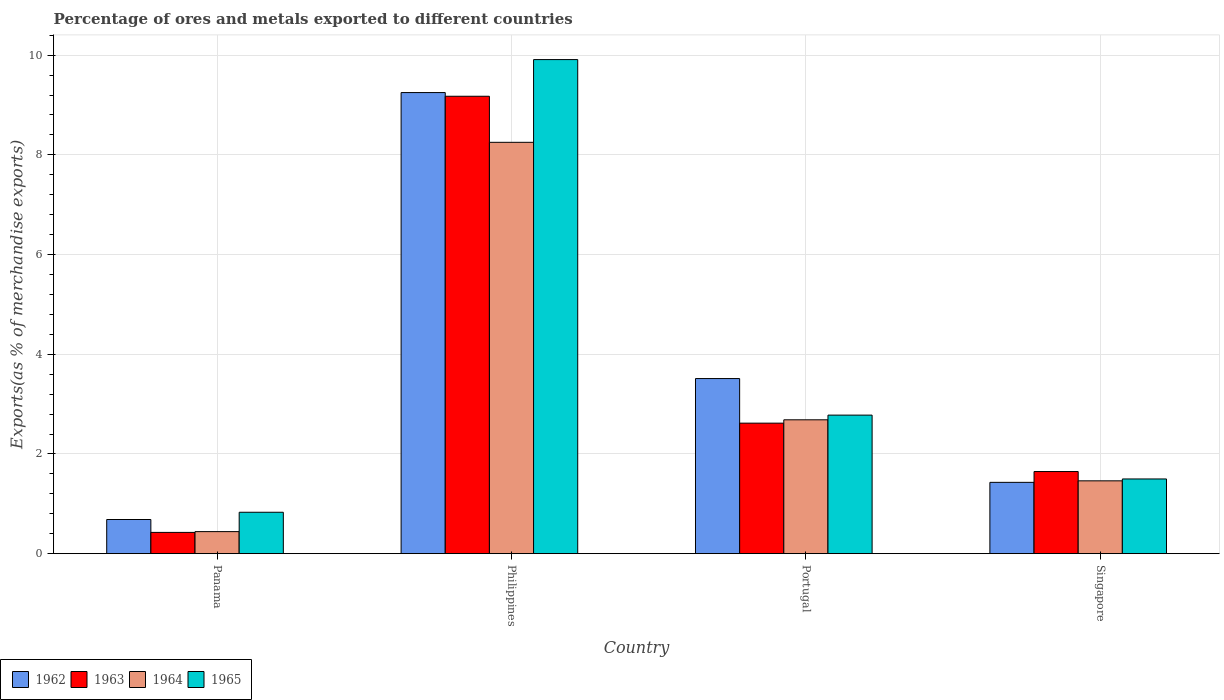How many different coloured bars are there?
Provide a succinct answer. 4. Are the number of bars per tick equal to the number of legend labels?
Give a very brief answer. Yes. Are the number of bars on each tick of the X-axis equal?
Make the answer very short. Yes. How many bars are there on the 3rd tick from the right?
Offer a terse response. 4. What is the label of the 1st group of bars from the left?
Offer a terse response. Panama. In how many cases, is the number of bars for a given country not equal to the number of legend labels?
Your answer should be very brief. 0. What is the percentage of exports to different countries in 1965 in Panama?
Offer a very short reply. 0.83. Across all countries, what is the maximum percentage of exports to different countries in 1963?
Your answer should be compact. 9.18. Across all countries, what is the minimum percentage of exports to different countries in 1964?
Provide a succinct answer. 0.44. In which country was the percentage of exports to different countries in 1963 minimum?
Ensure brevity in your answer.  Panama. What is the total percentage of exports to different countries in 1965 in the graph?
Your answer should be very brief. 15.02. What is the difference between the percentage of exports to different countries in 1963 in Portugal and that in Singapore?
Your response must be concise. 0.97. What is the difference between the percentage of exports to different countries in 1964 in Singapore and the percentage of exports to different countries in 1965 in Portugal?
Ensure brevity in your answer.  -1.32. What is the average percentage of exports to different countries in 1963 per country?
Offer a terse response. 3.47. What is the difference between the percentage of exports to different countries of/in 1963 and percentage of exports to different countries of/in 1962 in Portugal?
Ensure brevity in your answer.  -0.89. What is the ratio of the percentage of exports to different countries in 1962 in Panama to that in Singapore?
Make the answer very short. 0.48. Is the percentage of exports to different countries in 1962 in Panama less than that in Philippines?
Provide a succinct answer. Yes. What is the difference between the highest and the second highest percentage of exports to different countries in 1964?
Keep it short and to the point. 6.79. What is the difference between the highest and the lowest percentage of exports to different countries in 1963?
Offer a very short reply. 8.75. In how many countries, is the percentage of exports to different countries in 1964 greater than the average percentage of exports to different countries in 1964 taken over all countries?
Provide a short and direct response. 1. Is the sum of the percentage of exports to different countries in 1963 in Philippines and Singapore greater than the maximum percentage of exports to different countries in 1962 across all countries?
Ensure brevity in your answer.  Yes. What does the 1st bar from the right in Panama represents?
Your response must be concise. 1965. What is the difference between two consecutive major ticks on the Y-axis?
Make the answer very short. 2. Does the graph contain any zero values?
Provide a succinct answer. No. How are the legend labels stacked?
Keep it short and to the point. Horizontal. What is the title of the graph?
Your response must be concise. Percentage of ores and metals exported to different countries. What is the label or title of the X-axis?
Your answer should be very brief. Country. What is the label or title of the Y-axis?
Keep it short and to the point. Exports(as % of merchandise exports). What is the Exports(as % of merchandise exports) in 1962 in Panama?
Provide a short and direct response. 0.69. What is the Exports(as % of merchandise exports) of 1963 in Panama?
Provide a short and direct response. 0.43. What is the Exports(as % of merchandise exports) in 1964 in Panama?
Your response must be concise. 0.44. What is the Exports(as % of merchandise exports) of 1965 in Panama?
Ensure brevity in your answer.  0.83. What is the Exports(as % of merchandise exports) in 1962 in Philippines?
Provide a short and direct response. 9.25. What is the Exports(as % of merchandise exports) of 1963 in Philippines?
Your answer should be very brief. 9.18. What is the Exports(as % of merchandise exports) in 1964 in Philippines?
Your answer should be very brief. 8.25. What is the Exports(as % of merchandise exports) of 1965 in Philippines?
Offer a very short reply. 9.91. What is the Exports(as % of merchandise exports) in 1962 in Portugal?
Make the answer very short. 3.51. What is the Exports(as % of merchandise exports) in 1963 in Portugal?
Make the answer very short. 2.62. What is the Exports(as % of merchandise exports) in 1964 in Portugal?
Offer a terse response. 2.69. What is the Exports(as % of merchandise exports) of 1965 in Portugal?
Your answer should be compact. 2.78. What is the Exports(as % of merchandise exports) of 1962 in Singapore?
Provide a short and direct response. 1.43. What is the Exports(as % of merchandise exports) of 1963 in Singapore?
Provide a short and direct response. 1.65. What is the Exports(as % of merchandise exports) of 1964 in Singapore?
Provide a short and direct response. 1.46. What is the Exports(as % of merchandise exports) of 1965 in Singapore?
Your response must be concise. 1.5. Across all countries, what is the maximum Exports(as % of merchandise exports) in 1962?
Your answer should be compact. 9.25. Across all countries, what is the maximum Exports(as % of merchandise exports) of 1963?
Your response must be concise. 9.18. Across all countries, what is the maximum Exports(as % of merchandise exports) of 1964?
Give a very brief answer. 8.25. Across all countries, what is the maximum Exports(as % of merchandise exports) in 1965?
Make the answer very short. 9.91. Across all countries, what is the minimum Exports(as % of merchandise exports) of 1962?
Keep it short and to the point. 0.69. Across all countries, what is the minimum Exports(as % of merchandise exports) in 1963?
Give a very brief answer. 0.43. Across all countries, what is the minimum Exports(as % of merchandise exports) of 1964?
Your answer should be compact. 0.44. Across all countries, what is the minimum Exports(as % of merchandise exports) in 1965?
Provide a short and direct response. 0.83. What is the total Exports(as % of merchandise exports) of 1962 in the graph?
Offer a very short reply. 14.88. What is the total Exports(as % of merchandise exports) in 1963 in the graph?
Your answer should be compact. 13.87. What is the total Exports(as % of merchandise exports) in 1964 in the graph?
Your answer should be very brief. 12.84. What is the total Exports(as % of merchandise exports) of 1965 in the graph?
Ensure brevity in your answer.  15.02. What is the difference between the Exports(as % of merchandise exports) of 1962 in Panama and that in Philippines?
Your answer should be compact. -8.56. What is the difference between the Exports(as % of merchandise exports) of 1963 in Panama and that in Philippines?
Give a very brief answer. -8.75. What is the difference between the Exports(as % of merchandise exports) of 1964 in Panama and that in Philippines?
Keep it short and to the point. -7.81. What is the difference between the Exports(as % of merchandise exports) of 1965 in Panama and that in Philippines?
Ensure brevity in your answer.  -9.08. What is the difference between the Exports(as % of merchandise exports) in 1962 in Panama and that in Portugal?
Offer a terse response. -2.83. What is the difference between the Exports(as % of merchandise exports) in 1963 in Panama and that in Portugal?
Offer a very short reply. -2.19. What is the difference between the Exports(as % of merchandise exports) of 1964 in Panama and that in Portugal?
Keep it short and to the point. -2.24. What is the difference between the Exports(as % of merchandise exports) in 1965 in Panama and that in Portugal?
Offer a terse response. -1.95. What is the difference between the Exports(as % of merchandise exports) of 1962 in Panama and that in Singapore?
Offer a very short reply. -0.75. What is the difference between the Exports(as % of merchandise exports) of 1963 in Panama and that in Singapore?
Ensure brevity in your answer.  -1.22. What is the difference between the Exports(as % of merchandise exports) of 1964 in Panama and that in Singapore?
Your answer should be compact. -1.02. What is the difference between the Exports(as % of merchandise exports) of 1965 in Panama and that in Singapore?
Provide a short and direct response. -0.67. What is the difference between the Exports(as % of merchandise exports) of 1962 in Philippines and that in Portugal?
Provide a short and direct response. 5.74. What is the difference between the Exports(as % of merchandise exports) of 1963 in Philippines and that in Portugal?
Make the answer very short. 6.56. What is the difference between the Exports(as % of merchandise exports) in 1964 in Philippines and that in Portugal?
Provide a short and direct response. 5.57. What is the difference between the Exports(as % of merchandise exports) of 1965 in Philippines and that in Portugal?
Your answer should be compact. 7.13. What is the difference between the Exports(as % of merchandise exports) in 1962 in Philippines and that in Singapore?
Give a very brief answer. 7.82. What is the difference between the Exports(as % of merchandise exports) of 1963 in Philippines and that in Singapore?
Provide a short and direct response. 7.53. What is the difference between the Exports(as % of merchandise exports) in 1964 in Philippines and that in Singapore?
Keep it short and to the point. 6.79. What is the difference between the Exports(as % of merchandise exports) of 1965 in Philippines and that in Singapore?
Keep it short and to the point. 8.41. What is the difference between the Exports(as % of merchandise exports) in 1962 in Portugal and that in Singapore?
Give a very brief answer. 2.08. What is the difference between the Exports(as % of merchandise exports) in 1963 in Portugal and that in Singapore?
Give a very brief answer. 0.97. What is the difference between the Exports(as % of merchandise exports) of 1964 in Portugal and that in Singapore?
Offer a terse response. 1.22. What is the difference between the Exports(as % of merchandise exports) of 1965 in Portugal and that in Singapore?
Provide a succinct answer. 1.28. What is the difference between the Exports(as % of merchandise exports) of 1962 in Panama and the Exports(as % of merchandise exports) of 1963 in Philippines?
Give a very brief answer. -8.49. What is the difference between the Exports(as % of merchandise exports) in 1962 in Panama and the Exports(as % of merchandise exports) in 1964 in Philippines?
Provide a short and direct response. -7.57. What is the difference between the Exports(as % of merchandise exports) of 1962 in Panama and the Exports(as % of merchandise exports) of 1965 in Philippines?
Provide a short and direct response. -9.23. What is the difference between the Exports(as % of merchandise exports) of 1963 in Panama and the Exports(as % of merchandise exports) of 1964 in Philippines?
Make the answer very short. -7.83. What is the difference between the Exports(as % of merchandise exports) of 1963 in Panama and the Exports(as % of merchandise exports) of 1965 in Philippines?
Offer a terse response. -9.49. What is the difference between the Exports(as % of merchandise exports) of 1964 in Panama and the Exports(as % of merchandise exports) of 1965 in Philippines?
Provide a succinct answer. -9.47. What is the difference between the Exports(as % of merchandise exports) of 1962 in Panama and the Exports(as % of merchandise exports) of 1963 in Portugal?
Keep it short and to the point. -1.93. What is the difference between the Exports(as % of merchandise exports) in 1962 in Panama and the Exports(as % of merchandise exports) in 1965 in Portugal?
Provide a short and direct response. -2.09. What is the difference between the Exports(as % of merchandise exports) in 1963 in Panama and the Exports(as % of merchandise exports) in 1964 in Portugal?
Give a very brief answer. -2.26. What is the difference between the Exports(as % of merchandise exports) in 1963 in Panama and the Exports(as % of merchandise exports) in 1965 in Portugal?
Offer a terse response. -2.35. What is the difference between the Exports(as % of merchandise exports) in 1964 in Panama and the Exports(as % of merchandise exports) in 1965 in Portugal?
Give a very brief answer. -2.34. What is the difference between the Exports(as % of merchandise exports) of 1962 in Panama and the Exports(as % of merchandise exports) of 1963 in Singapore?
Keep it short and to the point. -0.96. What is the difference between the Exports(as % of merchandise exports) in 1962 in Panama and the Exports(as % of merchandise exports) in 1964 in Singapore?
Give a very brief answer. -0.78. What is the difference between the Exports(as % of merchandise exports) of 1962 in Panama and the Exports(as % of merchandise exports) of 1965 in Singapore?
Your answer should be compact. -0.81. What is the difference between the Exports(as % of merchandise exports) in 1963 in Panama and the Exports(as % of merchandise exports) in 1964 in Singapore?
Provide a succinct answer. -1.03. What is the difference between the Exports(as % of merchandise exports) in 1963 in Panama and the Exports(as % of merchandise exports) in 1965 in Singapore?
Your answer should be compact. -1.07. What is the difference between the Exports(as % of merchandise exports) in 1964 in Panama and the Exports(as % of merchandise exports) in 1965 in Singapore?
Provide a short and direct response. -1.06. What is the difference between the Exports(as % of merchandise exports) in 1962 in Philippines and the Exports(as % of merchandise exports) in 1963 in Portugal?
Give a very brief answer. 6.63. What is the difference between the Exports(as % of merchandise exports) of 1962 in Philippines and the Exports(as % of merchandise exports) of 1964 in Portugal?
Provide a short and direct response. 6.56. What is the difference between the Exports(as % of merchandise exports) of 1962 in Philippines and the Exports(as % of merchandise exports) of 1965 in Portugal?
Ensure brevity in your answer.  6.47. What is the difference between the Exports(as % of merchandise exports) in 1963 in Philippines and the Exports(as % of merchandise exports) in 1964 in Portugal?
Make the answer very short. 6.49. What is the difference between the Exports(as % of merchandise exports) in 1963 in Philippines and the Exports(as % of merchandise exports) in 1965 in Portugal?
Your answer should be very brief. 6.4. What is the difference between the Exports(as % of merchandise exports) in 1964 in Philippines and the Exports(as % of merchandise exports) in 1965 in Portugal?
Ensure brevity in your answer.  5.47. What is the difference between the Exports(as % of merchandise exports) in 1962 in Philippines and the Exports(as % of merchandise exports) in 1963 in Singapore?
Give a very brief answer. 7.6. What is the difference between the Exports(as % of merchandise exports) of 1962 in Philippines and the Exports(as % of merchandise exports) of 1964 in Singapore?
Provide a short and direct response. 7.79. What is the difference between the Exports(as % of merchandise exports) in 1962 in Philippines and the Exports(as % of merchandise exports) in 1965 in Singapore?
Keep it short and to the point. 7.75. What is the difference between the Exports(as % of merchandise exports) in 1963 in Philippines and the Exports(as % of merchandise exports) in 1964 in Singapore?
Keep it short and to the point. 7.72. What is the difference between the Exports(as % of merchandise exports) of 1963 in Philippines and the Exports(as % of merchandise exports) of 1965 in Singapore?
Give a very brief answer. 7.68. What is the difference between the Exports(as % of merchandise exports) of 1964 in Philippines and the Exports(as % of merchandise exports) of 1965 in Singapore?
Your answer should be very brief. 6.75. What is the difference between the Exports(as % of merchandise exports) in 1962 in Portugal and the Exports(as % of merchandise exports) in 1963 in Singapore?
Provide a succinct answer. 1.87. What is the difference between the Exports(as % of merchandise exports) in 1962 in Portugal and the Exports(as % of merchandise exports) in 1964 in Singapore?
Make the answer very short. 2.05. What is the difference between the Exports(as % of merchandise exports) in 1962 in Portugal and the Exports(as % of merchandise exports) in 1965 in Singapore?
Your answer should be compact. 2.01. What is the difference between the Exports(as % of merchandise exports) of 1963 in Portugal and the Exports(as % of merchandise exports) of 1964 in Singapore?
Offer a very short reply. 1.16. What is the difference between the Exports(as % of merchandise exports) in 1963 in Portugal and the Exports(as % of merchandise exports) in 1965 in Singapore?
Offer a very short reply. 1.12. What is the difference between the Exports(as % of merchandise exports) of 1964 in Portugal and the Exports(as % of merchandise exports) of 1965 in Singapore?
Offer a terse response. 1.19. What is the average Exports(as % of merchandise exports) in 1962 per country?
Your answer should be compact. 3.72. What is the average Exports(as % of merchandise exports) of 1963 per country?
Ensure brevity in your answer.  3.47. What is the average Exports(as % of merchandise exports) of 1964 per country?
Offer a very short reply. 3.21. What is the average Exports(as % of merchandise exports) in 1965 per country?
Provide a short and direct response. 3.76. What is the difference between the Exports(as % of merchandise exports) in 1962 and Exports(as % of merchandise exports) in 1963 in Panama?
Provide a succinct answer. 0.26. What is the difference between the Exports(as % of merchandise exports) in 1962 and Exports(as % of merchandise exports) in 1964 in Panama?
Your answer should be very brief. 0.24. What is the difference between the Exports(as % of merchandise exports) in 1962 and Exports(as % of merchandise exports) in 1965 in Panama?
Your answer should be compact. -0.15. What is the difference between the Exports(as % of merchandise exports) of 1963 and Exports(as % of merchandise exports) of 1964 in Panama?
Give a very brief answer. -0.02. What is the difference between the Exports(as % of merchandise exports) in 1963 and Exports(as % of merchandise exports) in 1965 in Panama?
Your response must be concise. -0.4. What is the difference between the Exports(as % of merchandise exports) of 1964 and Exports(as % of merchandise exports) of 1965 in Panama?
Keep it short and to the point. -0.39. What is the difference between the Exports(as % of merchandise exports) of 1962 and Exports(as % of merchandise exports) of 1963 in Philippines?
Your response must be concise. 0.07. What is the difference between the Exports(as % of merchandise exports) of 1962 and Exports(as % of merchandise exports) of 1965 in Philippines?
Keep it short and to the point. -0.66. What is the difference between the Exports(as % of merchandise exports) of 1963 and Exports(as % of merchandise exports) of 1964 in Philippines?
Provide a succinct answer. 0.92. What is the difference between the Exports(as % of merchandise exports) in 1963 and Exports(as % of merchandise exports) in 1965 in Philippines?
Keep it short and to the point. -0.74. What is the difference between the Exports(as % of merchandise exports) of 1964 and Exports(as % of merchandise exports) of 1965 in Philippines?
Ensure brevity in your answer.  -1.66. What is the difference between the Exports(as % of merchandise exports) of 1962 and Exports(as % of merchandise exports) of 1963 in Portugal?
Your answer should be compact. 0.89. What is the difference between the Exports(as % of merchandise exports) in 1962 and Exports(as % of merchandise exports) in 1964 in Portugal?
Offer a terse response. 0.83. What is the difference between the Exports(as % of merchandise exports) in 1962 and Exports(as % of merchandise exports) in 1965 in Portugal?
Offer a terse response. 0.73. What is the difference between the Exports(as % of merchandise exports) of 1963 and Exports(as % of merchandise exports) of 1964 in Portugal?
Provide a succinct answer. -0.07. What is the difference between the Exports(as % of merchandise exports) of 1963 and Exports(as % of merchandise exports) of 1965 in Portugal?
Keep it short and to the point. -0.16. What is the difference between the Exports(as % of merchandise exports) in 1964 and Exports(as % of merchandise exports) in 1965 in Portugal?
Offer a very short reply. -0.09. What is the difference between the Exports(as % of merchandise exports) in 1962 and Exports(as % of merchandise exports) in 1963 in Singapore?
Keep it short and to the point. -0.22. What is the difference between the Exports(as % of merchandise exports) in 1962 and Exports(as % of merchandise exports) in 1964 in Singapore?
Offer a very short reply. -0.03. What is the difference between the Exports(as % of merchandise exports) of 1962 and Exports(as % of merchandise exports) of 1965 in Singapore?
Keep it short and to the point. -0.07. What is the difference between the Exports(as % of merchandise exports) of 1963 and Exports(as % of merchandise exports) of 1964 in Singapore?
Offer a very short reply. 0.19. What is the difference between the Exports(as % of merchandise exports) of 1963 and Exports(as % of merchandise exports) of 1965 in Singapore?
Your answer should be very brief. 0.15. What is the difference between the Exports(as % of merchandise exports) in 1964 and Exports(as % of merchandise exports) in 1965 in Singapore?
Provide a succinct answer. -0.04. What is the ratio of the Exports(as % of merchandise exports) of 1962 in Panama to that in Philippines?
Your response must be concise. 0.07. What is the ratio of the Exports(as % of merchandise exports) in 1963 in Panama to that in Philippines?
Your response must be concise. 0.05. What is the ratio of the Exports(as % of merchandise exports) in 1964 in Panama to that in Philippines?
Ensure brevity in your answer.  0.05. What is the ratio of the Exports(as % of merchandise exports) in 1965 in Panama to that in Philippines?
Ensure brevity in your answer.  0.08. What is the ratio of the Exports(as % of merchandise exports) in 1962 in Panama to that in Portugal?
Provide a succinct answer. 0.2. What is the ratio of the Exports(as % of merchandise exports) in 1963 in Panama to that in Portugal?
Your response must be concise. 0.16. What is the ratio of the Exports(as % of merchandise exports) in 1964 in Panama to that in Portugal?
Your answer should be very brief. 0.16. What is the ratio of the Exports(as % of merchandise exports) in 1965 in Panama to that in Portugal?
Provide a short and direct response. 0.3. What is the ratio of the Exports(as % of merchandise exports) of 1962 in Panama to that in Singapore?
Your response must be concise. 0.48. What is the ratio of the Exports(as % of merchandise exports) of 1963 in Panama to that in Singapore?
Offer a terse response. 0.26. What is the ratio of the Exports(as % of merchandise exports) of 1964 in Panama to that in Singapore?
Give a very brief answer. 0.3. What is the ratio of the Exports(as % of merchandise exports) of 1965 in Panama to that in Singapore?
Offer a very short reply. 0.55. What is the ratio of the Exports(as % of merchandise exports) in 1962 in Philippines to that in Portugal?
Provide a succinct answer. 2.63. What is the ratio of the Exports(as % of merchandise exports) of 1963 in Philippines to that in Portugal?
Make the answer very short. 3.5. What is the ratio of the Exports(as % of merchandise exports) of 1964 in Philippines to that in Portugal?
Ensure brevity in your answer.  3.07. What is the ratio of the Exports(as % of merchandise exports) in 1965 in Philippines to that in Portugal?
Provide a succinct answer. 3.57. What is the ratio of the Exports(as % of merchandise exports) in 1962 in Philippines to that in Singapore?
Offer a terse response. 6.47. What is the ratio of the Exports(as % of merchandise exports) in 1963 in Philippines to that in Singapore?
Offer a very short reply. 5.57. What is the ratio of the Exports(as % of merchandise exports) of 1964 in Philippines to that in Singapore?
Your answer should be very brief. 5.65. What is the ratio of the Exports(as % of merchandise exports) in 1965 in Philippines to that in Singapore?
Give a very brief answer. 6.61. What is the ratio of the Exports(as % of merchandise exports) in 1962 in Portugal to that in Singapore?
Keep it short and to the point. 2.46. What is the ratio of the Exports(as % of merchandise exports) of 1963 in Portugal to that in Singapore?
Give a very brief answer. 1.59. What is the ratio of the Exports(as % of merchandise exports) of 1964 in Portugal to that in Singapore?
Give a very brief answer. 1.84. What is the ratio of the Exports(as % of merchandise exports) in 1965 in Portugal to that in Singapore?
Your answer should be very brief. 1.85. What is the difference between the highest and the second highest Exports(as % of merchandise exports) in 1962?
Provide a short and direct response. 5.74. What is the difference between the highest and the second highest Exports(as % of merchandise exports) of 1963?
Provide a short and direct response. 6.56. What is the difference between the highest and the second highest Exports(as % of merchandise exports) in 1964?
Offer a terse response. 5.57. What is the difference between the highest and the second highest Exports(as % of merchandise exports) in 1965?
Your answer should be compact. 7.13. What is the difference between the highest and the lowest Exports(as % of merchandise exports) in 1962?
Make the answer very short. 8.56. What is the difference between the highest and the lowest Exports(as % of merchandise exports) of 1963?
Keep it short and to the point. 8.75. What is the difference between the highest and the lowest Exports(as % of merchandise exports) of 1964?
Provide a succinct answer. 7.81. What is the difference between the highest and the lowest Exports(as % of merchandise exports) of 1965?
Make the answer very short. 9.08. 